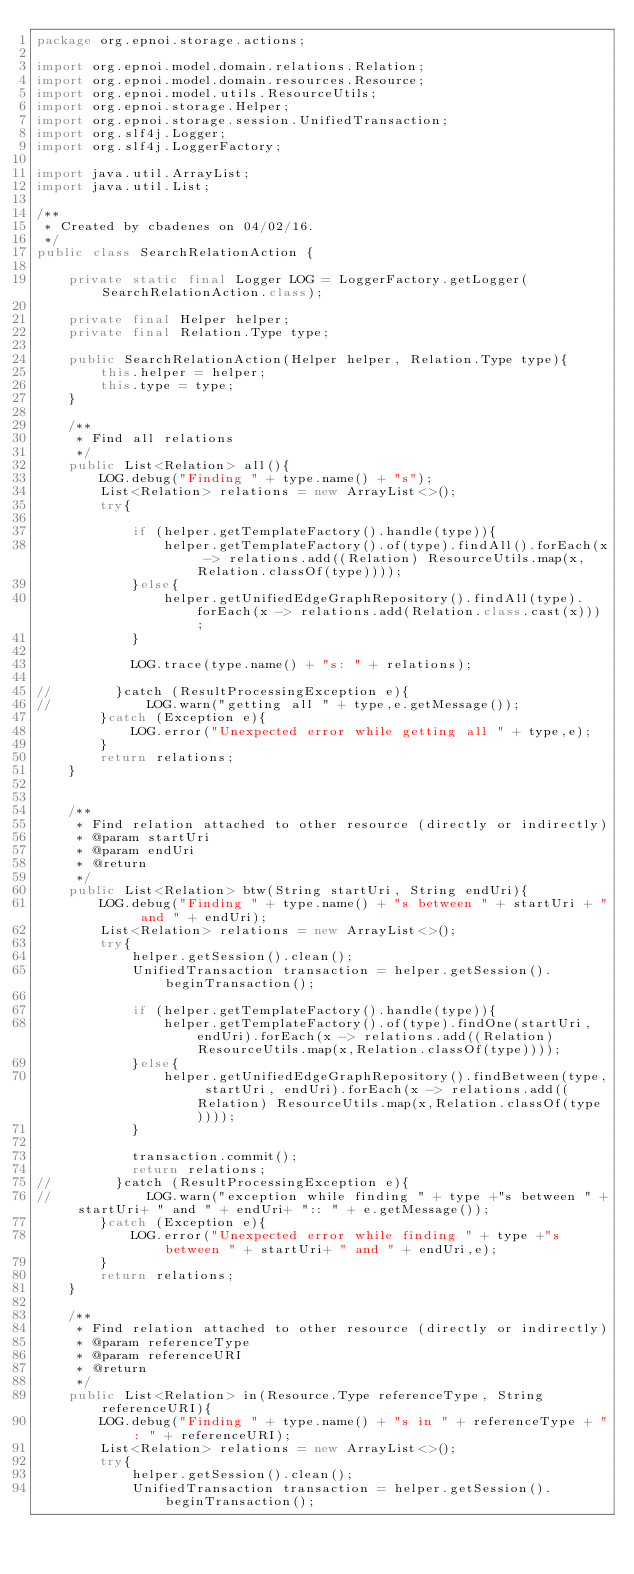<code> <loc_0><loc_0><loc_500><loc_500><_Java_>package org.epnoi.storage.actions;

import org.epnoi.model.domain.relations.Relation;
import org.epnoi.model.domain.resources.Resource;
import org.epnoi.model.utils.ResourceUtils;
import org.epnoi.storage.Helper;
import org.epnoi.storage.session.UnifiedTransaction;
import org.slf4j.Logger;
import org.slf4j.LoggerFactory;

import java.util.ArrayList;
import java.util.List;

/**
 * Created by cbadenes on 04/02/16.
 */
public class SearchRelationAction {

    private static final Logger LOG = LoggerFactory.getLogger(SearchRelationAction.class);

    private final Helper helper;
    private final Relation.Type type;

    public SearchRelationAction(Helper helper, Relation.Type type){
        this.helper = helper;
        this.type = type;
    }

    /**
     * Find all relations
     */
    public List<Relation> all(){
        LOG.debug("Finding " + type.name() + "s");
        List<Relation> relations = new ArrayList<>();
        try{

            if (helper.getTemplateFactory().handle(type)){
                helper.getTemplateFactory().of(type).findAll().forEach(x -> relations.add((Relation) ResourceUtils.map(x,Relation.classOf(type))));
            }else{
                helper.getUnifiedEdgeGraphRepository().findAll(type).forEach(x -> relations.add(Relation.class.cast(x)));
            }

            LOG.trace(type.name() + "s: " + relations);

//        }catch (ResultProcessingException e){
//            LOG.warn("getting all " + type,e.getMessage());
        }catch (Exception e){
            LOG.error("Unexpected error while getting all " + type,e);
        }
        return relations;
    }


    /**
     * Find relation attached to other resource (directly or indirectly)
     * @param startUri
     * @param endUri
     * @return
     */
    public List<Relation> btw(String startUri, String endUri){
        LOG.debug("Finding " + type.name() + "s between " + startUri + " and " + endUri);
        List<Relation> relations = new ArrayList<>();
        try{
            helper.getSession().clean();
            UnifiedTransaction transaction = helper.getSession().beginTransaction();

            if (helper.getTemplateFactory().handle(type)){
                helper.getTemplateFactory().of(type).findOne(startUri,endUri).forEach(x -> relations.add((Relation) ResourceUtils.map(x,Relation.classOf(type))));
            }else{
                helper.getUnifiedEdgeGraphRepository().findBetween(type, startUri, endUri).forEach(x -> relations.add((Relation) ResourceUtils.map(x,Relation.classOf(type))));
            }

            transaction.commit();
            return relations;
//        }catch (ResultProcessingException e){
//            LOG.warn("exception while finding " + type +"s between " + startUri+ " and " + endUri+ ":: " + e.getMessage());
        }catch (Exception e){
            LOG.error("Unexpected error while finding " + type +"s between " + startUri+ " and " + endUri,e);
        }
        return relations;
    }

    /**
     * Find relation attached to other resource (directly or indirectly)
     * @param referenceType
     * @param referenceURI
     * @return
     */
    public List<Relation> in(Resource.Type referenceType, String referenceURI){
        LOG.debug("Finding " + type.name() + "s in " + referenceType + ": " + referenceURI);
        List<Relation> relations = new ArrayList<>();
        try{
            helper.getSession().clean();
            UnifiedTransaction transaction = helper.getSession().beginTransaction();
</code> 